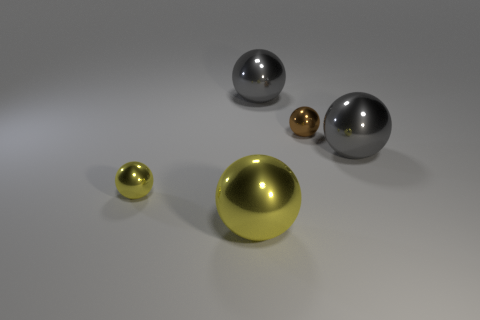Are the brown thing and the big yellow ball made of the same material?
Your answer should be very brief. Yes. How many large gray balls have the same material as the small brown object?
Provide a short and direct response. 2. What number of objects are either gray objects behind the tiny brown thing or gray shiny spheres right of the small brown metallic thing?
Ensure brevity in your answer.  2. Are there more tiny metal spheres to the left of the tiny yellow object than brown metallic things left of the large yellow metallic thing?
Provide a succinct answer. No. The big metallic object in front of the tiny yellow ball is what color?
Provide a succinct answer. Yellow. Are there any gray metallic objects of the same shape as the brown metal thing?
Provide a succinct answer. Yes. How many brown things are spheres or matte things?
Ensure brevity in your answer.  1. Is there a sphere that has the same size as the brown thing?
Give a very brief answer. Yes. How many big cyan metallic things are there?
Keep it short and to the point. 0. What number of large objects are gray metal balls or blue rubber cubes?
Your response must be concise. 2. 